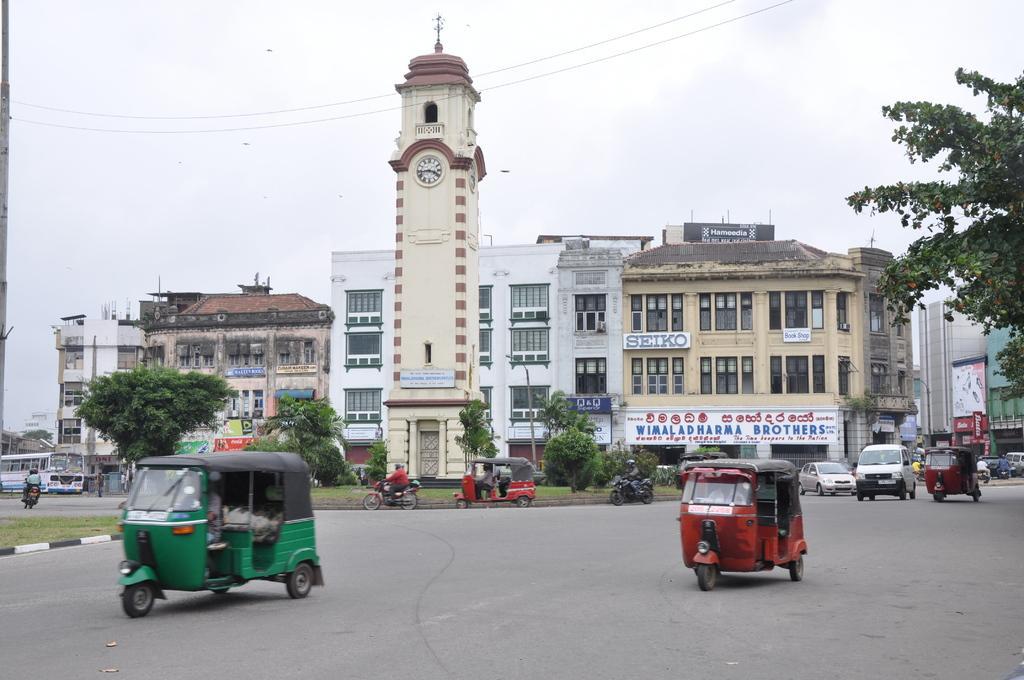Could you give a brief overview of what you see in this image? In this image we can see some buildings with windows, signboards and some text on it. We can also see a group of vehicles on the road and some people riding motor vehicles. We can also see some poles, wires, trees, a clock tower and the sky which looks cloudy. 